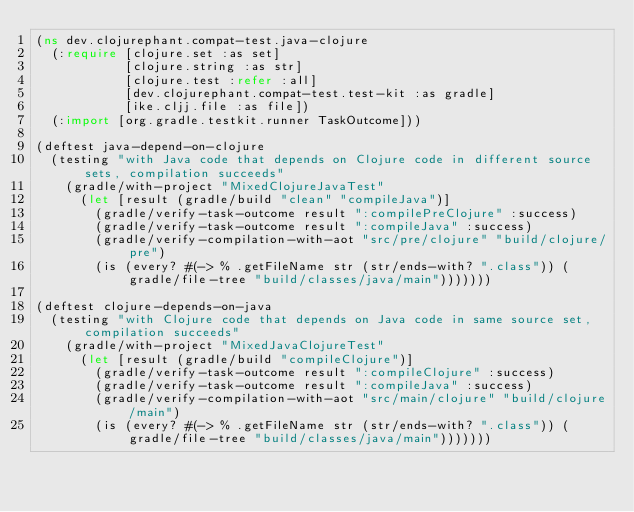Convert code to text. <code><loc_0><loc_0><loc_500><loc_500><_Clojure_>(ns dev.clojurephant.compat-test.java-clojure
  (:require [clojure.set :as set]
            [clojure.string :as str]
            [clojure.test :refer :all]
            [dev.clojurephant.compat-test.test-kit :as gradle]
            [ike.cljj.file :as file])
  (:import [org.gradle.testkit.runner TaskOutcome]))

(deftest java-depend-on-clojure
  (testing "with Java code that depends on Clojure code in different source sets, compilation succeeds"
    (gradle/with-project "MixedClojureJavaTest"
      (let [result (gradle/build "clean" "compileJava")]
        (gradle/verify-task-outcome result ":compilePreClojure" :success)
        (gradle/verify-task-outcome result ":compileJava" :success)
        (gradle/verify-compilation-with-aot "src/pre/clojure" "build/clojure/pre")
        (is (every? #(-> % .getFileName str (str/ends-with? ".class")) (gradle/file-tree "build/classes/java/main")))))))

(deftest clojure-depends-on-java
  (testing "with Clojure code that depends on Java code in same source set, compilation succeeds"
    (gradle/with-project "MixedJavaClojureTest"
      (let [result (gradle/build "compileClojure")]
        (gradle/verify-task-outcome result ":compileClojure" :success)
        (gradle/verify-task-outcome result ":compileJava" :success)
        (gradle/verify-compilation-with-aot "src/main/clojure" "build/clojure/main")
        (is (every? #(-> % .getFileName str (str/ends-with? ".class")) (gradle/file-tree "build/classes/java/main")))))))
</code> 